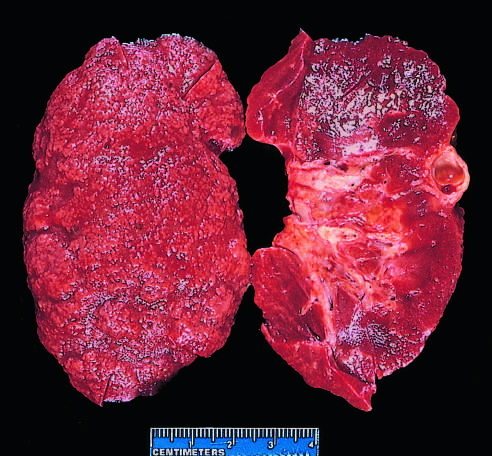what does the bisected kidney demonstrate?
Answer the question using a single word or phrase. Diffuse granular transformation of surface and marked thinning of cortex 